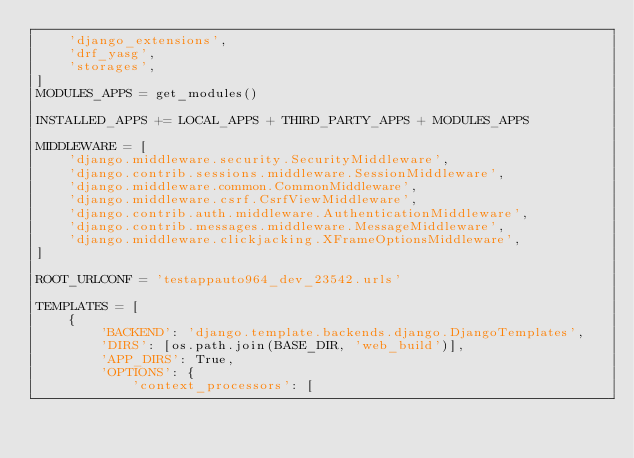<code> <loc_0><loc_0><loc_500><loc_500><_Python_>    'django_extensions',
    'drf_yasg',
    'storages',
]
MODULES_APPS = get_modules()

INSTALLED_APPS += LOCAL_APPS + THIRD_PARTY_APPS + MODULES_APPS

MIDDLEWARE = [
    'django.middleware.security.SecurityMiddleware',
    'django.contrib.sessions.middleware.SessionMiddleware',
    'django.middleware.common.CommonMiddleware',
    'django.middleware.csrf.CsrfViewMiddleware',
    'django.contrib.auth.middleware.AuthenticationMiddleware',
    'django.contrib.messages.middleware.MessageMiddleware',
    'django.middleware.clickjacking.XFrameOptionsMiddleware',
]

ROOT_URLCONF = 'testappauto964_dev_23542.urls'

TEMPLATES = [
    {
        'BACKEND': 'django.template.backends.django.DjangoTemplates',
        'DIRS': [os.path.join(BASE_DIR, 'web_build')],
        'APP_DIRS': True,
        'OPTIONS': {
            'context_processors': [</code> 